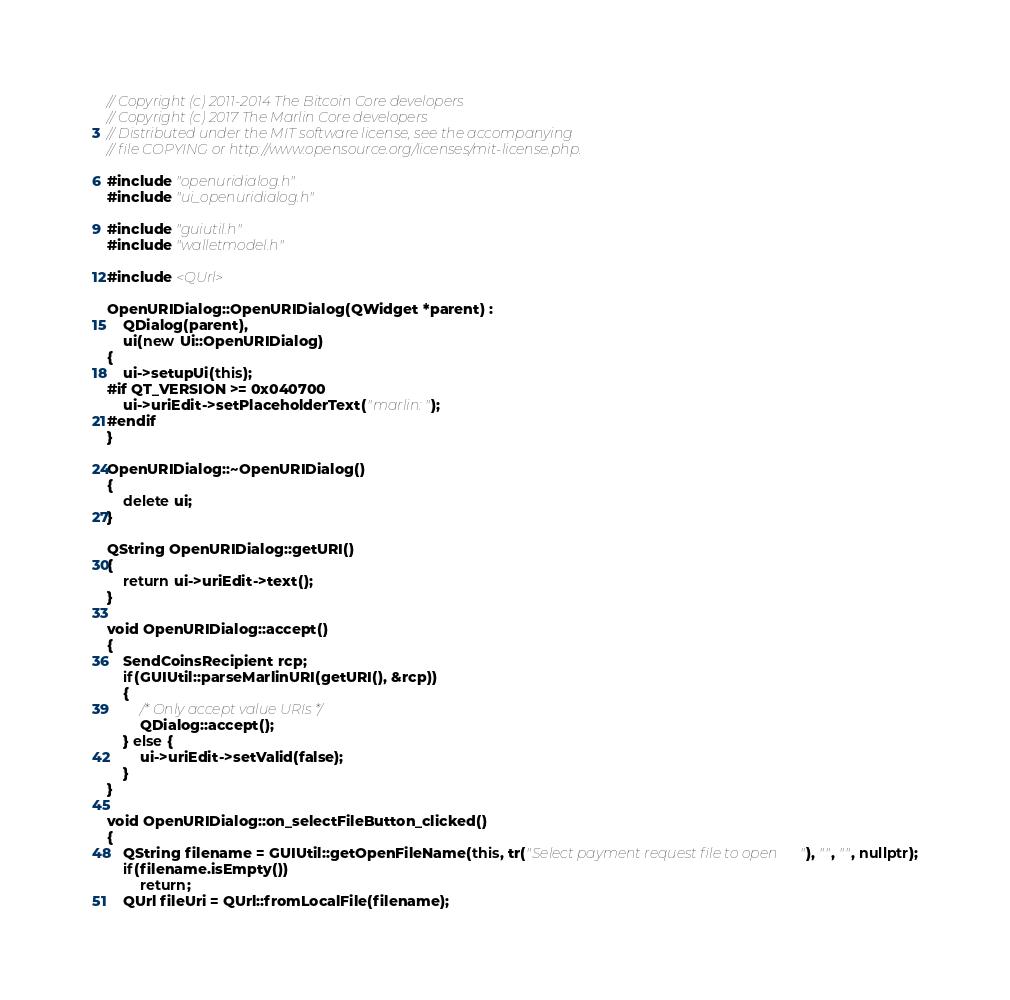<code> <loc_0><loc_0><loc_500><loc_500><_C++_>// Copyright (c) 2011-2014 The Bitcoin Core developers
// Copyright (c) 2017 The Marlin Core developers
// Distributed under the MIT software license, see the accompanying
// file COPYING or http://www.opensource.org/licenses/mit-license.php.

#include "openuridialog.h"
#include "ui_openuridialog.h"

#include "guiutil.h"
#include "walletmodel.h"

#include <QUrl>

OpenURIDialog::OpenURIDialog(QWidget *parent) :
    QDialog(parent),
    ui(new Ui::OpenURIDialog)
{
    ui->setupUi(this);
#if QT_VERSION >= 0x040700
    ui->uriEdit->setPlaceholderText("marlin:");
#endif
}

OpenURIDialog::~OpenURIDialog()
{
    delete ui;
}

QString OpenURIDialog::getURI()
{
    return ui->uriEdit->text();
}

void OpenURIDialog::accept()
{
    SendCoinsRecipient rcp;
    if(GUIUtil::parseMarlinURI(getURI(), &rcp))
    {
        /* Only accept value URIs */
        QDialog::accept();
    } else {
        ui->uriEdit->setValid(false);
    }
}

void OpenURIDialog::on_selectFileButton_clicked()
{
    QString filename = GUIUtil::getOpenFileName(this, tr("Select payment request file to open"), "", "", nullptr);
    if(filename.isEmpty())
        return;
    QUrl fileUri = QUrl::fromLocalFile(filename);</code> 